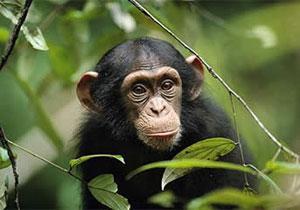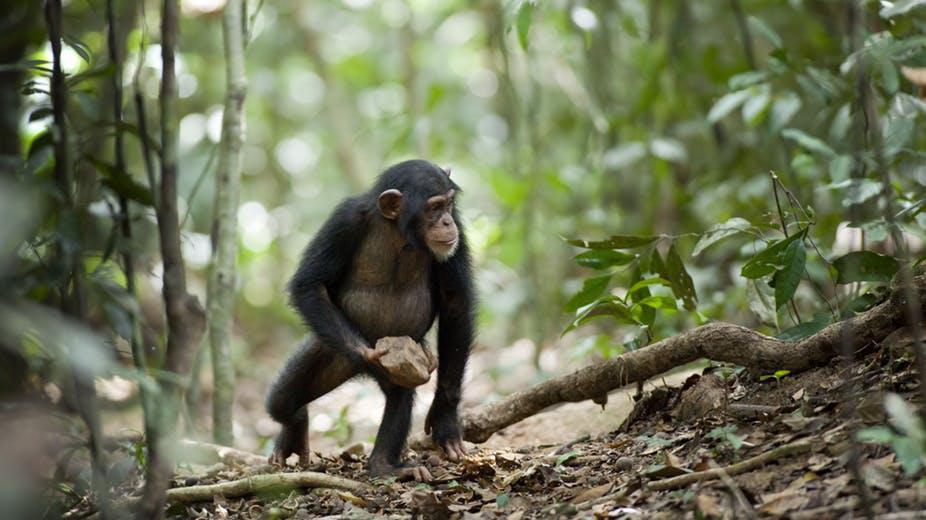The first image is the image on the left, the second image is the image on the right. For the images displayed, is the sentence "There are chimpanzees sitting on a suspended tree branch." factually correct? Answer yes or no. No. The first image is the image on the left, the second image is the image on the right. For the images displayed, is the sentence "At least one chimp is squatting on a somewhat horizontal branch, surrounded by foliage." factually correct? Answer yes or no. No. 